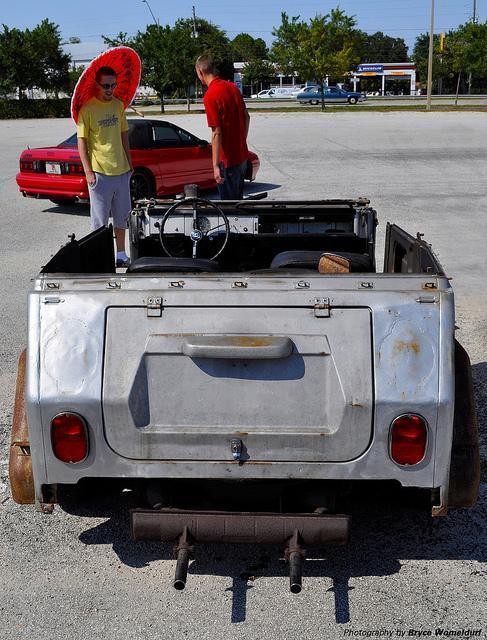How many people can be seen?
Give a very brief answer. 2. How many giraffes are standing up?
Give a very brief answer. 0. 